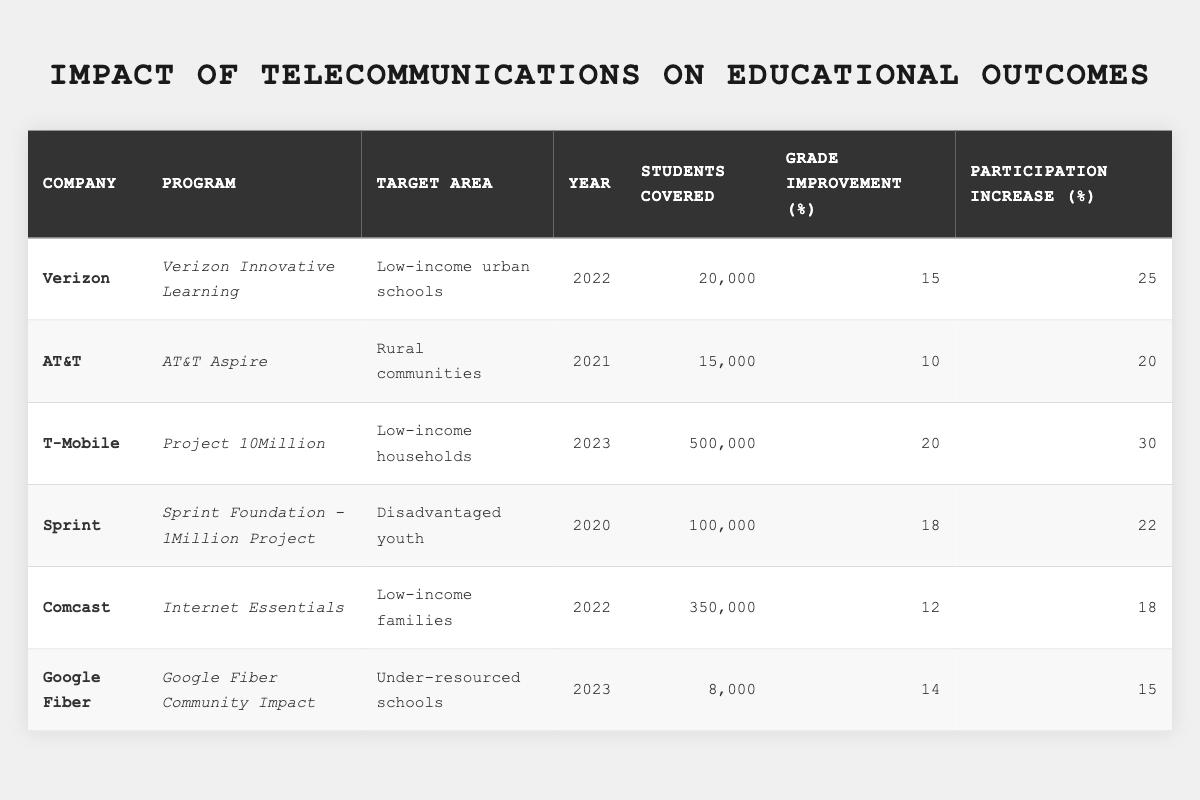What program had the highest number of students covered? By looking at the "Students Covered" column, the highest value is 500,000, which corresponds to T-Mobile's "Project 10Million."
Answer: T-Mobile's Project 10Million Which company showed the greatest improvement in grades? The "Improvement in Grades" column shows a maximum of 20% from T-Mobile's program, which is the highest percentage listed.
Answer: T-Mobile Did Verizon's program increase participation by at least 25%? Yes, Verizon's program had an increase in participation of 25%, as shown in the "Participation Increase" column.
Answer: Yes What was the average improvement in grades for all the programs listed? The improvement percentages are 15, 10, 20, 18, 12, and 14. Adding these gives 99, and dividing by the 6 programs results in an average of 16.5%.
Answer: 16.5% How many more students did T-Mobile cover compared to Comcast? T-Mobile covered 500,000 students and Comcast covered 350,000. The difference is 500,000 - 350,000 = 150,000.
Answer: 150,000 Which company's program had the lowest increase in student participation? Looking at the "Participation Increase" column, Comcast's program had the lowest increase at 18%.
Answer: Comcast How many students were covered by programs that improved grades by more than 15%? The programs with more than 15% improvement are Verizon (20,000), T-Mobile (500,000), and Sprint (100,000). Summing these gives 20,000 + 500,000 + 100,000 = 620,000 students covered.
Answer: 620,000 Is there a program targeting rural areas that improved grades by 10% or more? Yes, AT&T's program targets rural communities and improved grades by 10%, which meets the criteria.
Answer: Yes What is the total participation increase across all companies? The participation increases are 25, 20, 30, 22, 18, and 15. Adding these gives 25 + 20 + 30 + 22 + 18 + 15 = 140%.
Answer: 140% Which company had a program that targeted under-resourced schools? Google Fiber's program targets under-resourced schools, as indicated in the "Target Area" column.
Answer: Google Fiber 